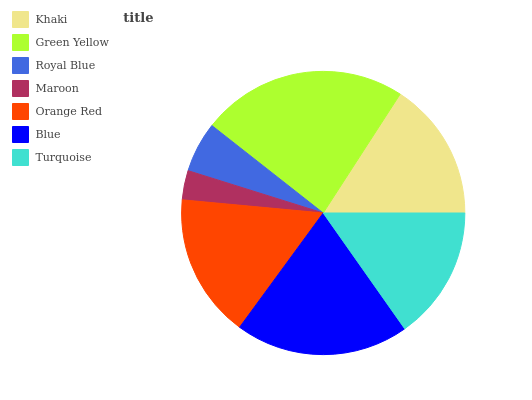Is Maroon the minimum?
Answer yes or no. Yes. Is Green Yellow the maximum?
Answer yes or no. Yes. Is Royal Blue the minimum?
Answer yes or no. No. Is Royal Blue the maximum?
Answer yes or no. No. Is Green Yellow greater than Royal Blue?
Answer yes or no. Yes. Is Royal Blue less than Green Yellow?
Answer yes or no. Yes. Is Royal Blue greater than Green Yellow?
Answer yes or no. No. Is Green Yellow less than Royal Blue?
Answer yes or no. No. Is Khaki the high median?
Answer yes or no. Yes. Is Khaki the low median?
Answer yes or no. Yes. Is Green Yellow the high median?
Answer yes or no. No. Is Blue the low median?
Answer yes or no. No. 